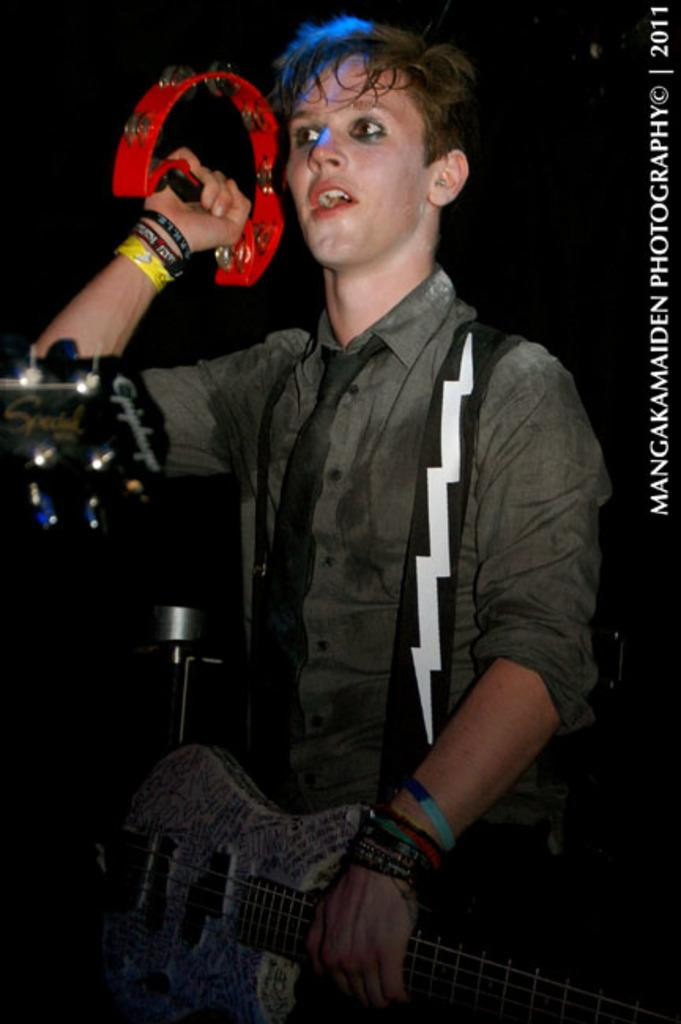Who is the main subject in the image? There is a man in the middle of the image. What is the man wearing? The man is wearing a shirt and tie. What is the man holding in the image? The man is holding a guitar, which is a musical instrument. Can you describe the text on the right side of the image? Unfortunately, the provided facts do not mention any details about the text on the right side of the image. What type of throne is the man sitting on in the image? There is no throne present in the image; the man is standing and holding a guitar. What type of club does the man belong to in the image? There is no mention of a club or any affiliation in the image. 